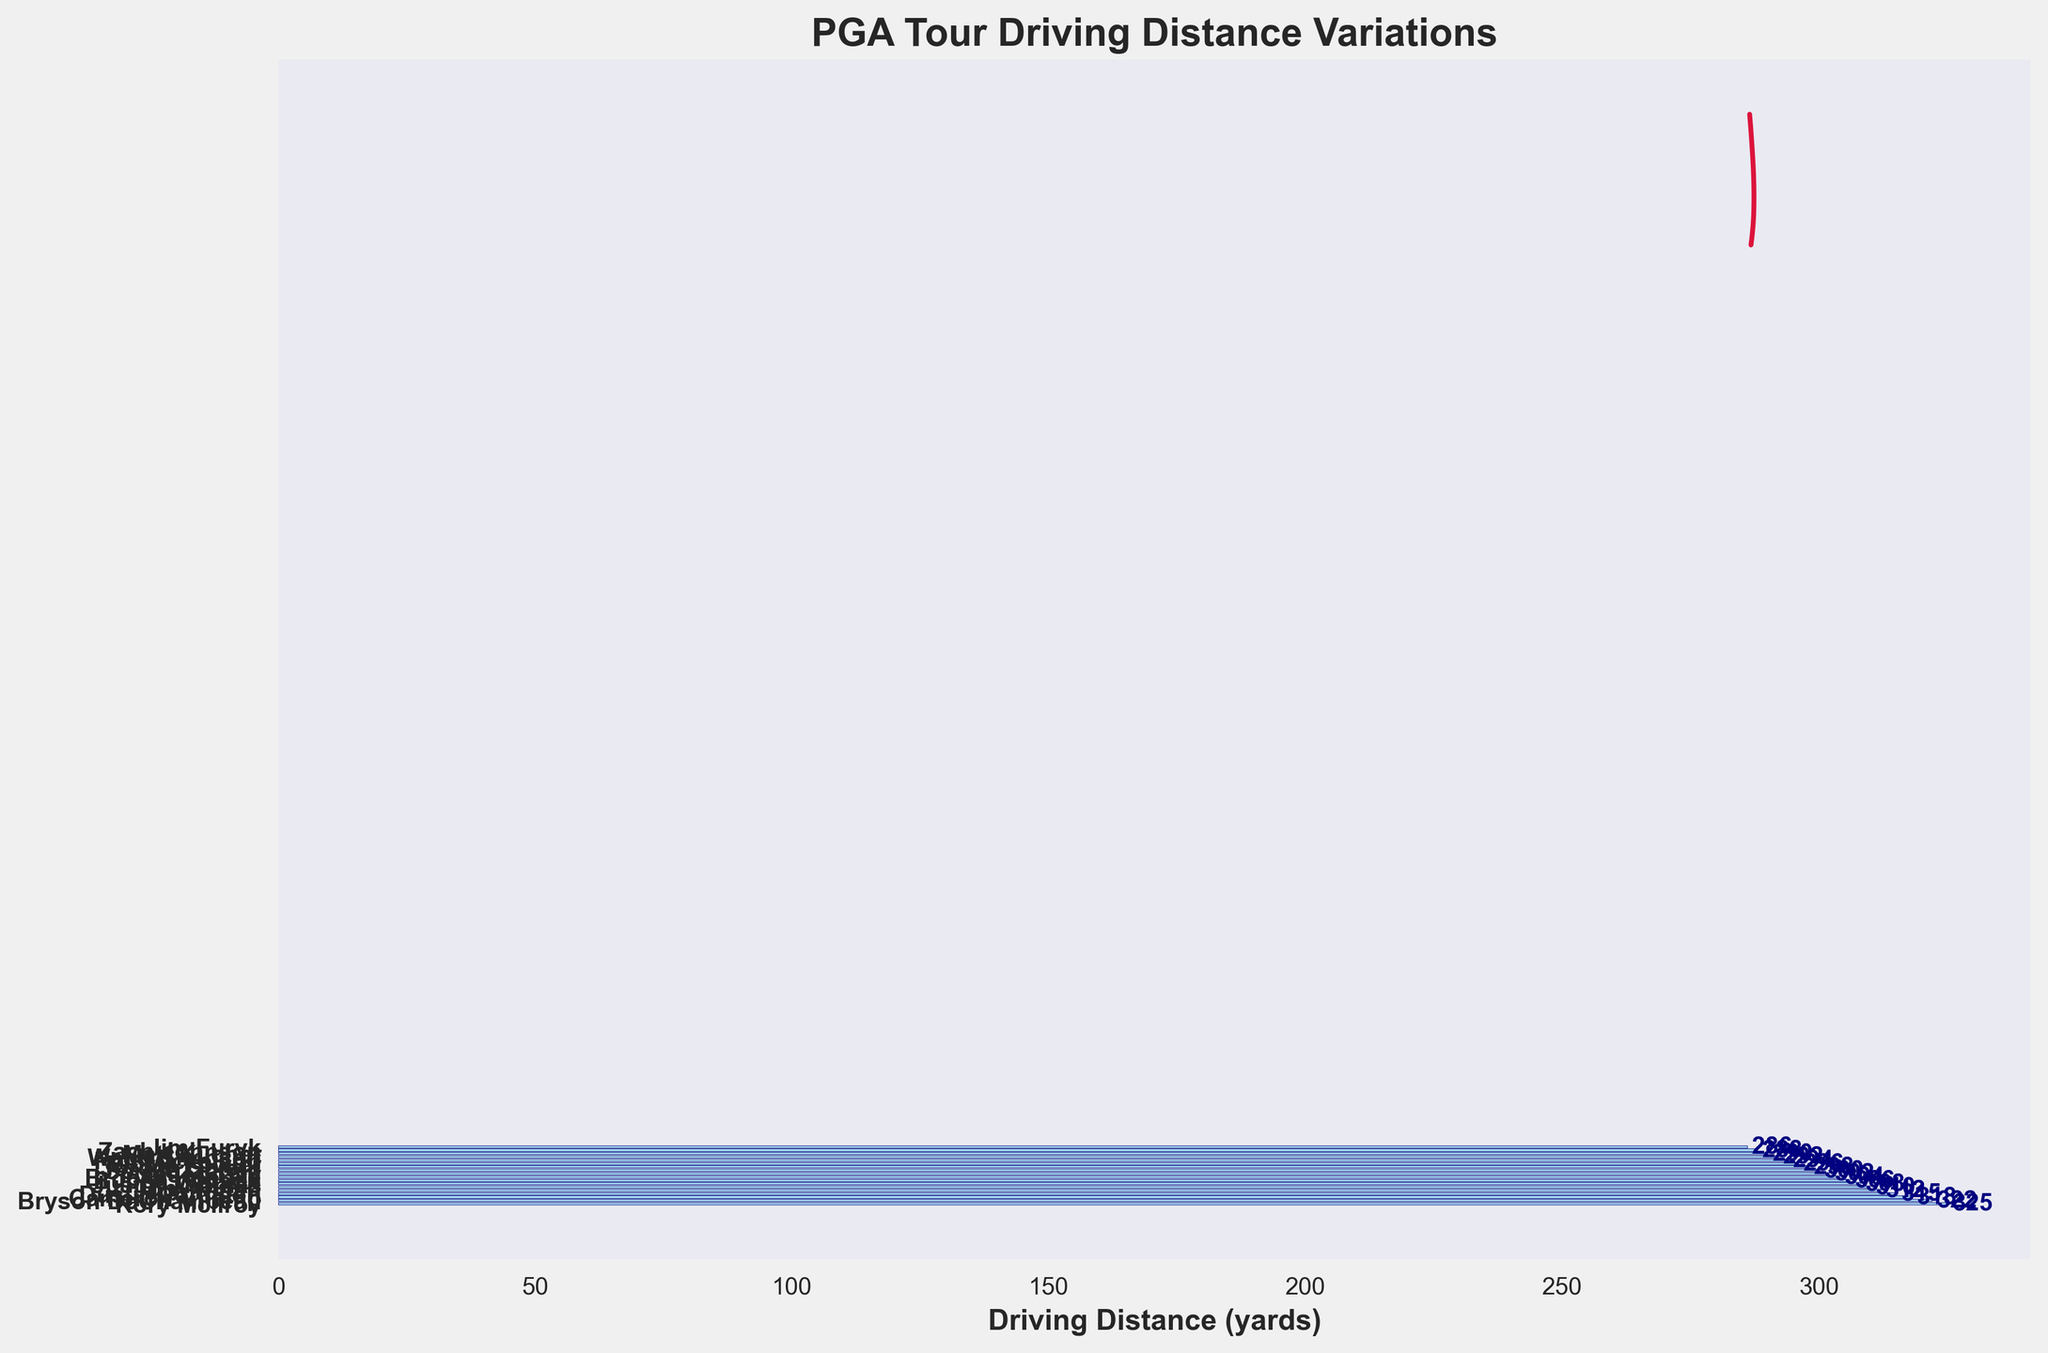What's the title of the figure? The title is written at the top of the figure. It provides a summary of what the figure represents.
Answer: PGA Tour Driving Distance Variations How is the driving distance data represented on the plot? The driving distance data is represented by horizontal bars, and each bar's length corresponds to the driving distance for each golfer.
Answer: Horizontal bars Which golfer has the shortest driving distance? The shortest driving distance bar is the one at the bottom of the plot. The label next to it indicates the golfer's name.
Answer: Jim Furyk What's the driving distance of Dustin Johnson? The horizontal bar associated with Dustin Johnson's name has a label at the end showing his driving distance.
Answer: 315 yards Which golfer has the longest driving distance and what is it? The longest bar at the top of the plot represents the golfer with the highest driving distance. The label next to it provides the name and distance.
Answer: Rory McIlroy, 325 yards What is the driving distance range shown in the plot? The driving distance range can be determined by subtracting the smallest driving distance (Jim Furyk's) from the largest driving distance (Rory McIlroy's).
Answer: 325 - 286 = 39 yards What is the average driving distance of these golfers? Add all the driving distances together and divide by the number of golfers. The average is calculated as follows: (325 + 322 + 318 + 315 + 312 + 310 + 308 + 306 + 304 + 302 + 300 + 298 + 296 + 294 + 292 + 290 + 288 + 286) / 18.
Answer: 304.67 yards How does Brooks Koepka's driving distance compare to Rickie Fowler's? Brooks Koepka's driving distance is represented by a horizontal bar along with a numeric label. Compare it with the label next to Rickie Fowler's bar.
Answer: Brooks Koepka's is greater (304 yards vs. 296 yards) Do any golfers have the same driving distance? Observe the horizontal bars and their labels to check if any two golfers share the same numeric value for driving distance.
Answer: No What does the crimson line on the plot represent? The crimson line shows the density estimate of the driving distance distribution. It's a smooth curve that indicates where the data points are concentrated.
Answer: Density estimation How many golfers have a driving distance greater than 310 yards? Count the number of bars that extend beyond the 310-yard mark.
Answer: 5 